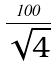<formula> <loc_0><loc_0><loc_500><loc_500>\frac { 1 0 0 } { \sqrt { 4 } }</formula> 